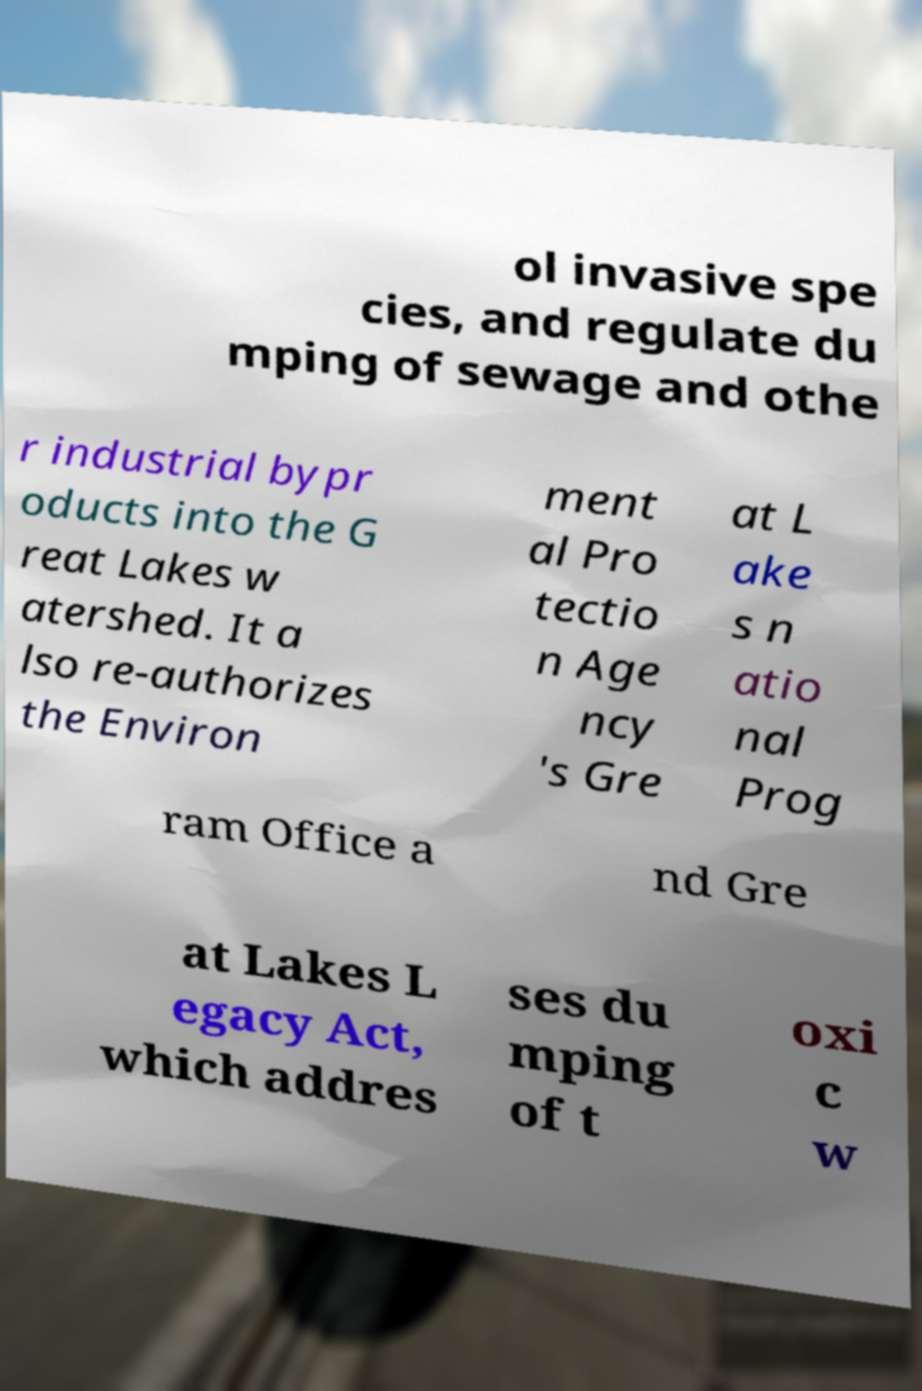Please identify and transcribe the text found in this image. ol invasive spe cies, and regulate du mping of sewage and othe r industrial bypr oducts into the G reat Lakes w atershed. It a lso re-authorizes the Environ ment al Pro tectio n Age ncy 's Gre at L ake s n atio nal Prog ram Office a nd Gre at Lakes L egacy Act, which addres ses du mping of t oxi c w 